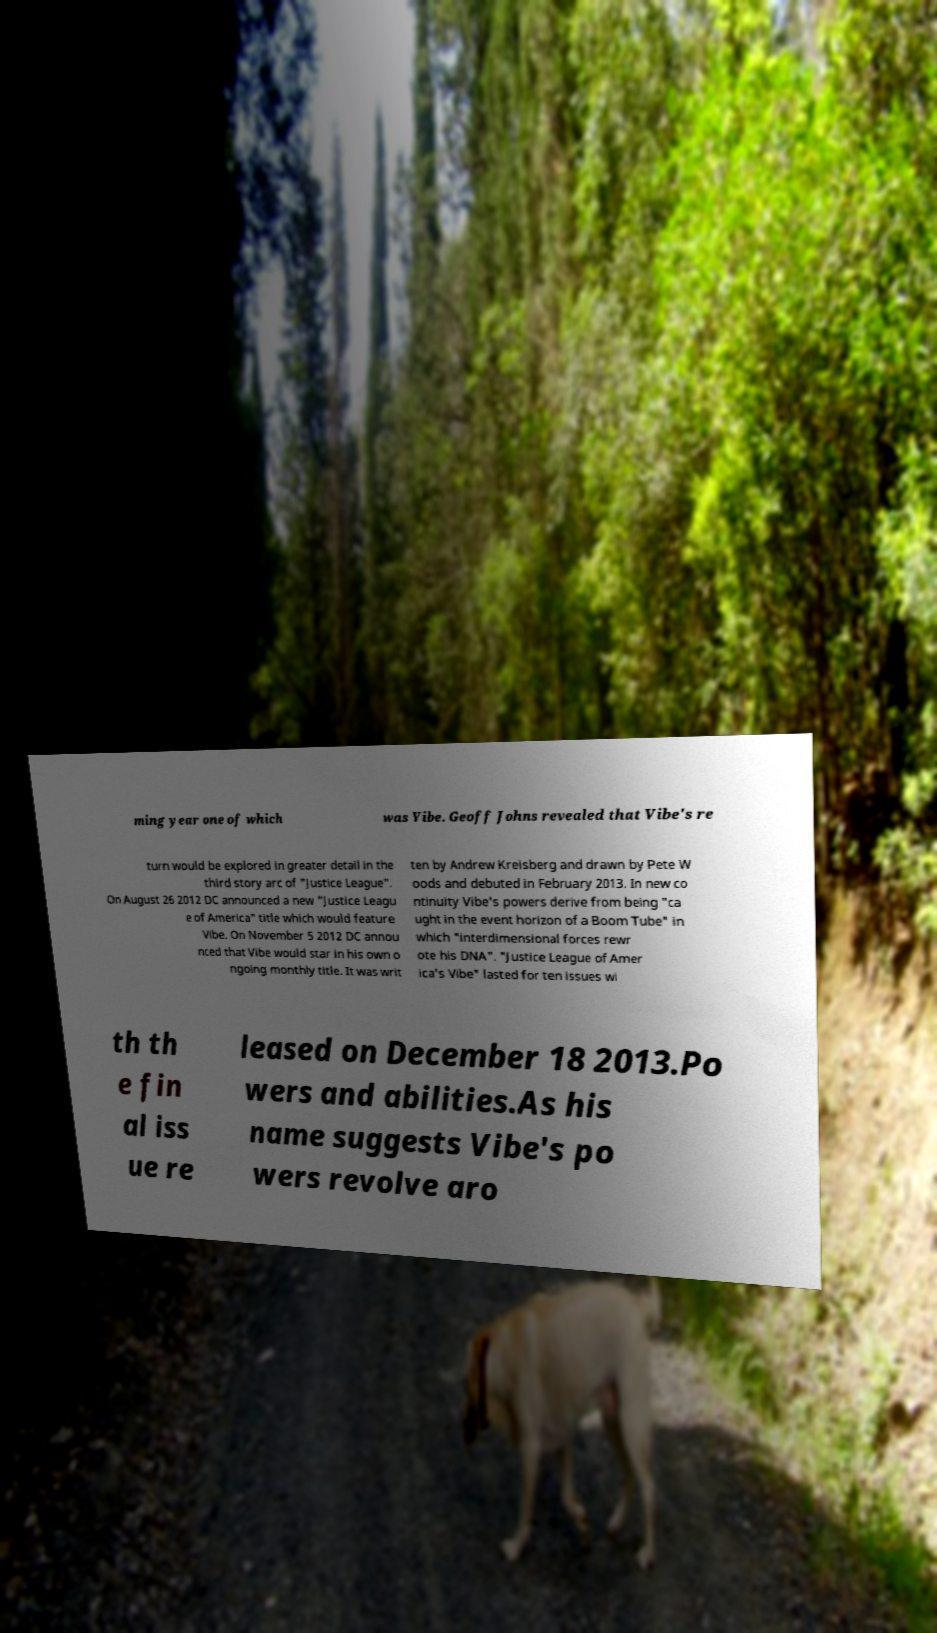Please read and relay the text visible in this image. What does it say? ming year one of which was Vibe. Geoff Johns revealed that Vibe's re turn would be explored in greater detail in the third story arc of "Justice League". On August 26 2012 DC announced a new "Justice Leagu e of America" title which would feature Vibe. On November 5 2012 DC annou nced that Vibe would star in his own o ngoing monthly title. It was writ ten by Andrew Kreisberg and drawn by Pete W oods and debuted in February 2013. In new co ntinuity Vibe's powers derive from being "ca ught in the event horizon of a Boom Tube" in which "interdimensional forces rewr ote his DNA". "Justice League of Amer ica's Vibe" lasted for ten issues wi th th e fin al iss ue re leased on December 18 2013.Po wers and abilities.As his name suggests Vibe's po wers revolve aro 